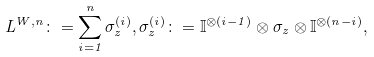<formula> <loc_0><loc_0><loc_500><loc_500>L ^ { W , n } \colon = \sum _ { i = 1 } ^ { n } \sigma ^ { ( i ) } _ { z } , \sigma ^ { ( i ) } _ { z } \colon = \mathbb { I } ^ { \otimes ( i - 1 ) } \otimes \sigma _ { z } \otimes \mathbb { I } ^ { \otimes ( n - i ) } ,</formula> 